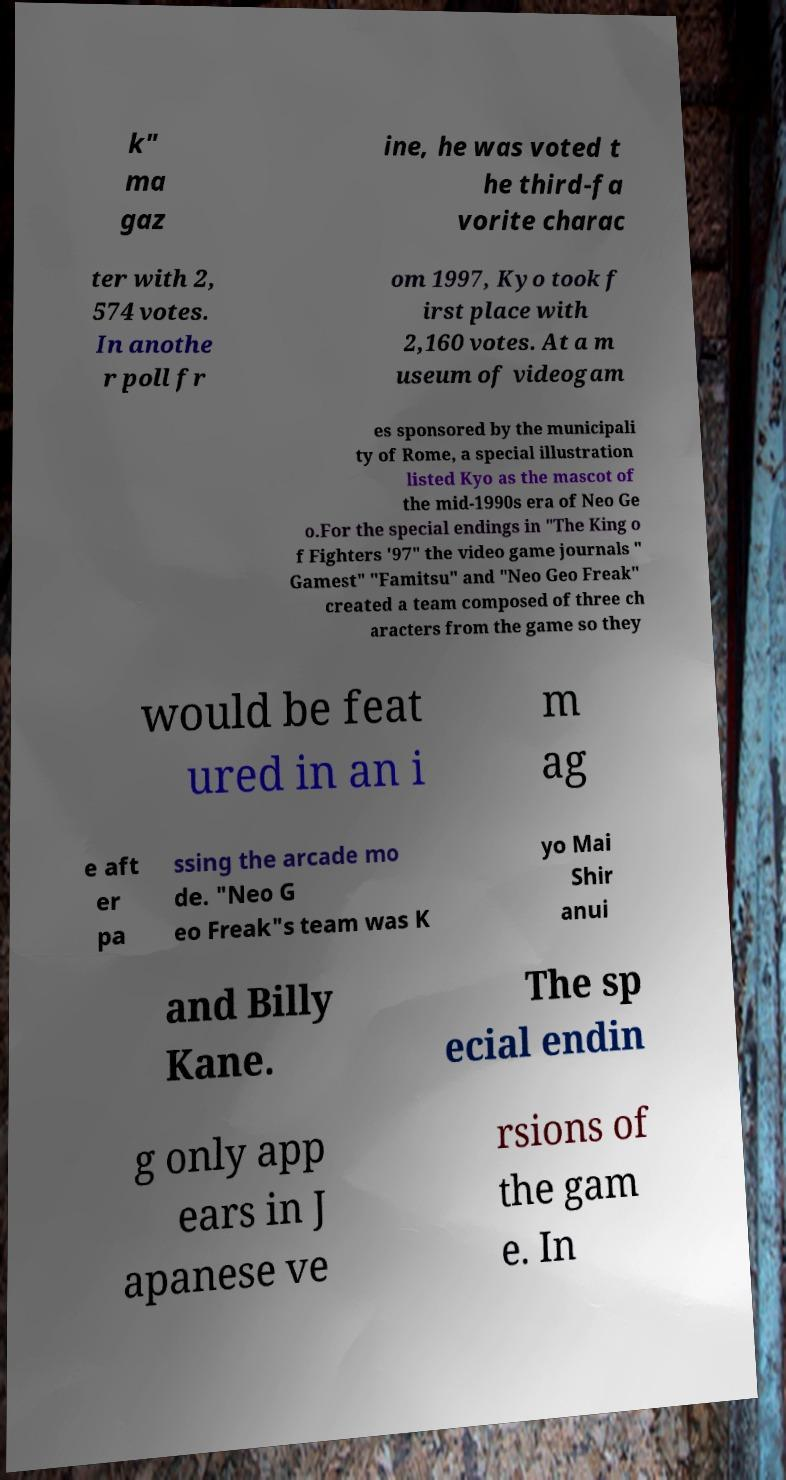There's text embedded in this image that I need extracted. Can you transcribe it verbatim? k" ma gaz ine, he was voted t he third-fa vorite charac ter with 2, 574 votes. In anothe r poll fr om 1997, Kyo took f irst place with 2,160 votes. At a m useum of videogam es sponsored by the municipali ty of Rome, a special illustration listed Kyo as the mascot of the mid-1990s era of Neo Ge o.For the special endings in "The King o f Fighters '97" the video game journals " Gamest" "Famitsu" and "Neo Geo Freak" created a team composed of three ch aracters from the game so they would be feat ured in an i m ag e aft er pa ssing the arcade mo de. "Neo G eo Freak"s team was K yo Mai Shir anui and Billy Kane. The sp ecial endin g only app ears in J apanese ve rsions of the gam e. In 